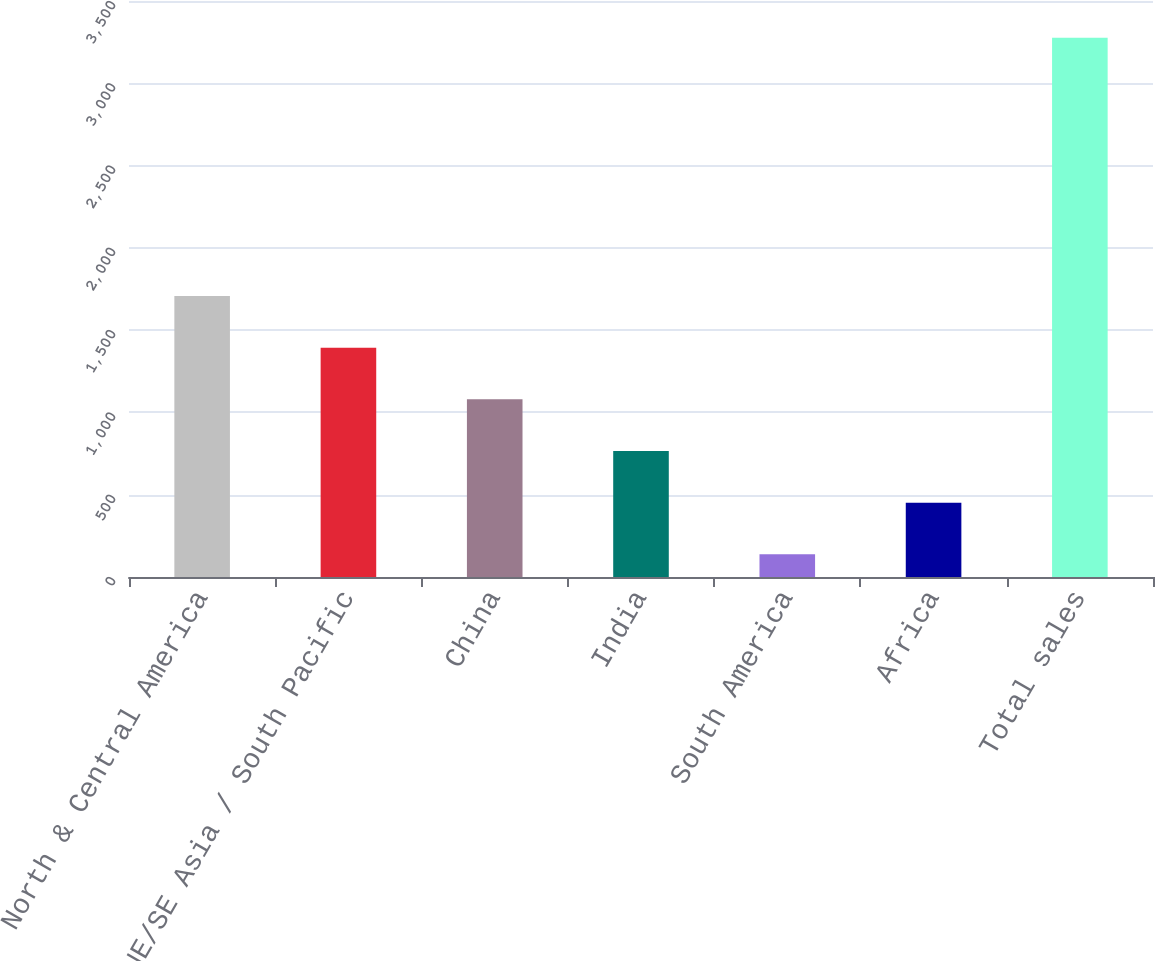Convert chart to OTSL. <chart><loc_0><loc_0><loc_500><loc_500><bar_chart><fcel>North & Central America<fcel>NE/SE Asia / South Pacific<fcel>China<fcel>India<fcel>South America<fcel>Africa<fcel>Total sales<nl><fcel>1707.5<fcel>1393.6<fcel>1079.7<fcel>765.8<fcel>138<fcel>451.9<fcel>3277<nl></chart> 